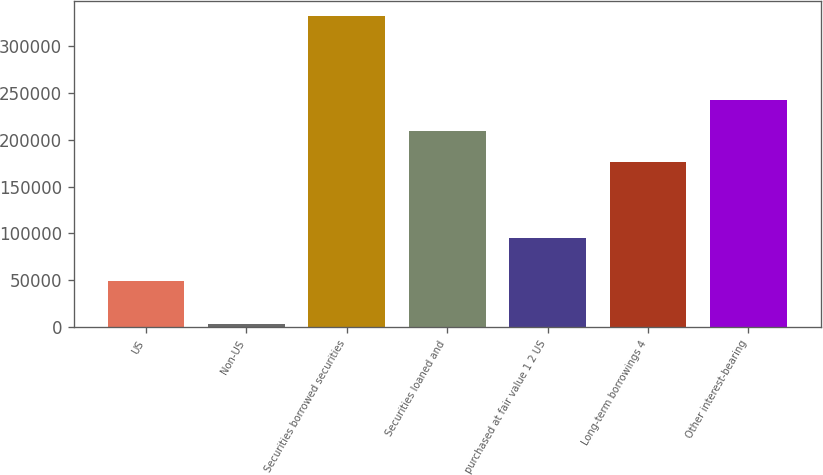Convert chart to OTSL. <chart><loc_0><loc_0><loc_500><loc_500><bar_chart><fcel>US<fcel>Non-US<fcel>Securities borrowed securities<fcel>Securities loaned and<fcel>purchased at fair value 1 2 US<fcel>Long-term borrowings 4<fcel>Other interest-bearing<nl><fcel>49123<fcel>3377<fcel>331828<fcel>209543<fcel>94740<fcel>176698<fcel>242388<nl></chart> 